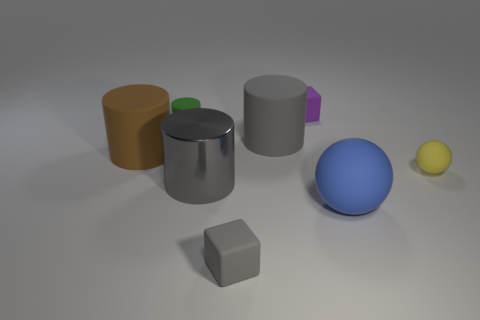Are there fewer yellow things than big blue matte cubes? Actually, the count of yellow objects and big blue matte cubes is the same. There is one of each: a small yellow ball and a big blue cube with a matte surface. So it's incorrect to say there are fewer yellow things than blue matte cubes. 